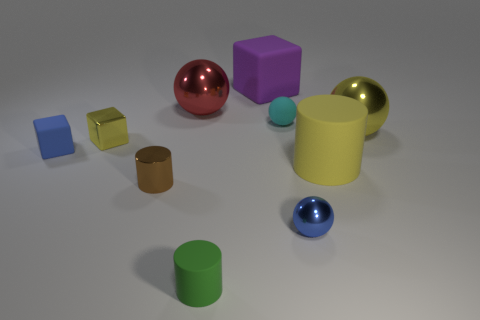Are the small ball that is in front of the blue block and the large yellow cylinder made of the same material?
Provide a short and direct response. No. There is a big matte object to the left of the blue object that is to the right of the matte thing that is left of the yellow metal block; what is its shape?
Your answer should be compact. Cube. Is there a cyan thing that has the same size as the brown object?
Provide a short and direct response. Yes. How big is the yellow matte cylinder?
Offer a very short reply. Large. How many blue rubber blocks have the same size as the purple block?
Provide a short and direct response. 0. Are there fewer balls left of the small matte ball than yellow rubber things to the left of the green matte object?
Offer a very short reply. No. There is a yellow object in front of the matte cube in front of the yellow shiny object right of the cyan matte ball; how big is it?
Give a very brief answer. Large. There is a object that is both behind the cyan matte sphere and to the left of the big cube; how big is it?
Provide a succinct answer. Large. There is a yellow thing left of the rubber thing that is behind the red ball; what is its shape?
Your response must be concise. Cube. Is there anything else of the same color as the big matte cylinder?
Make the answer very short. Yes. 